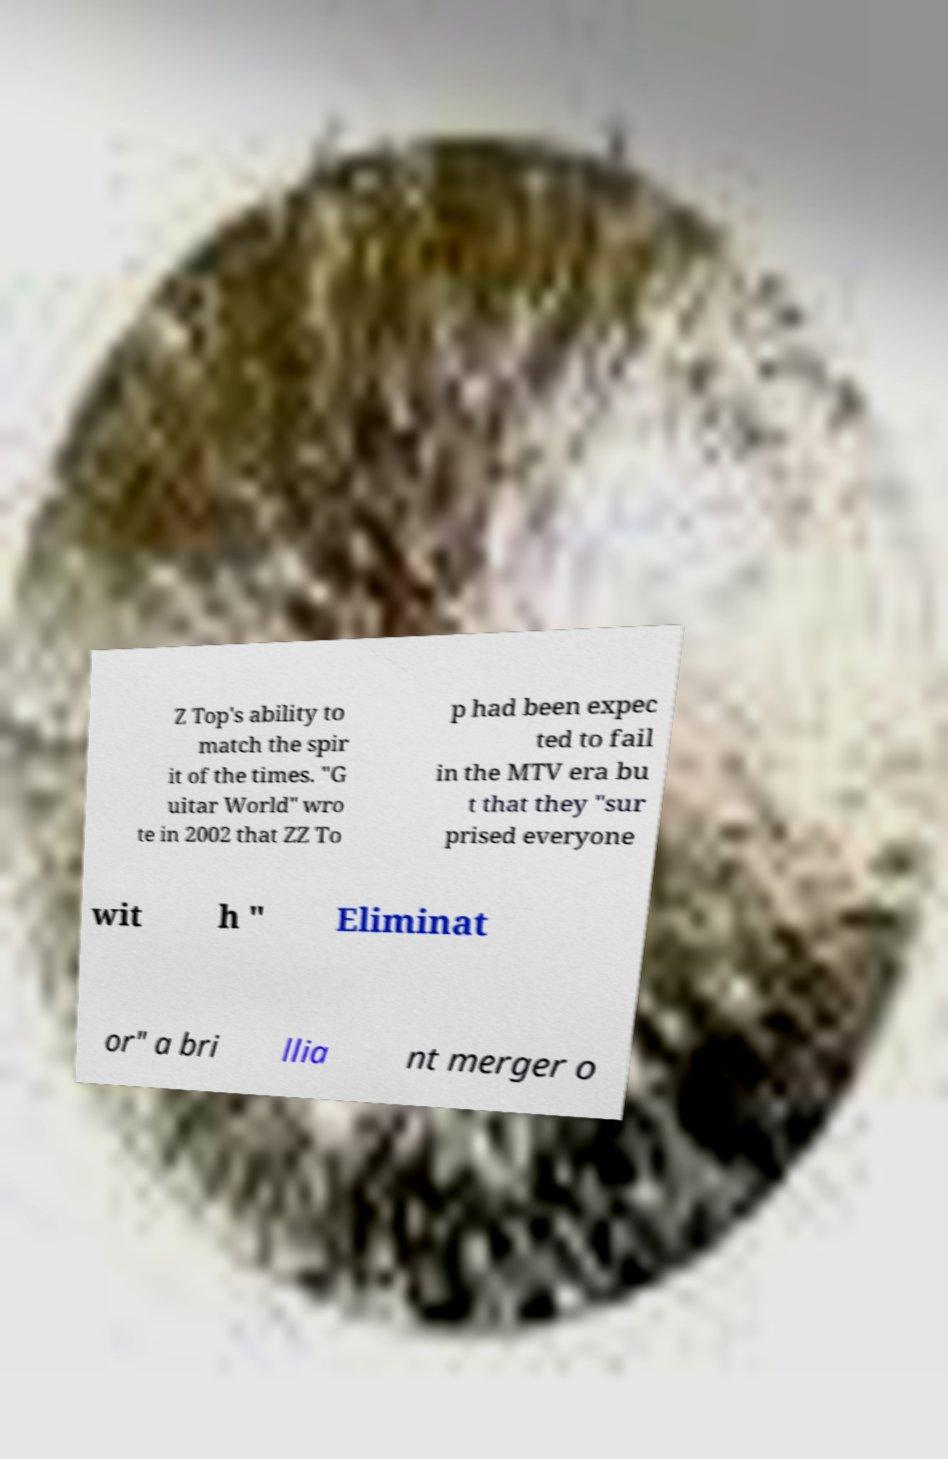Could you assist in decoding the text presented in this image and type it out clearly? Z Top's ability to match the spir it of the times. "G uitar World" wro te in 2002 that ZZ To p had been expec ted to fail in the MTV era bu t that they "sur prised everyone wit h " Eliminat or" a bri llia nt merger o 